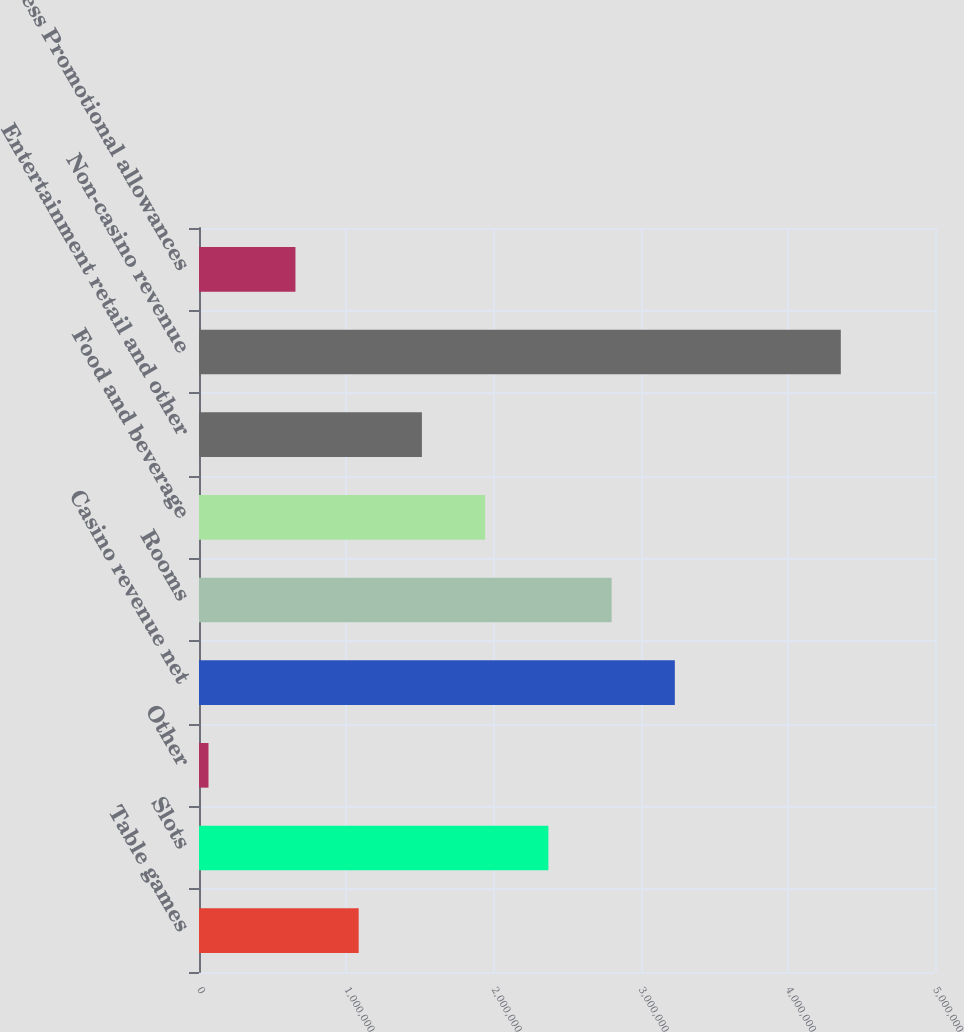Convert chart to OTSL. <chart><loc_0><loc_0><loc_500><loc_500><bar_chart><fcel>Table games<fcel>Slots<fcel>Other<fcel>Casino revenue net<fcel>Rooms<fcel>Food and beverage<fcel>Entertainment retail and other<fcel>Non-casino revenue<fcel>Less Promotional allowances<nl><fcel>1.08477e+06<fcel>2.37346e+06<fcel>64419<fcel>3.23259e+06<fcel>2.80303e+06<fcel>1.9439e+06<fcel>1.51434e+06<fcel>4.36005e+06<fcel>655211<nl></chart> 